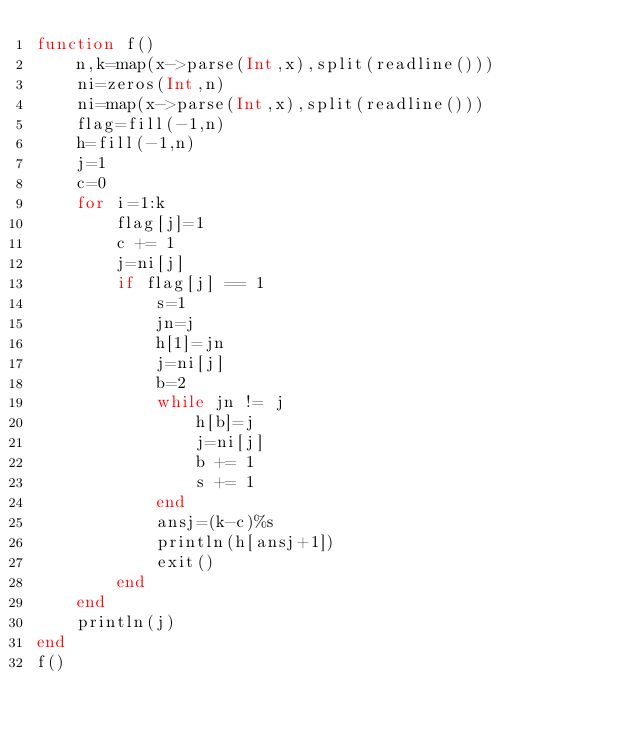Convert code to text. <code><loc_0><loc_0><loc_500><loc_500><_Julia_>function f()
    n,k=map(x->parse(Int,x),split(readline()))
    ni=zeros(Int,n)
    ni=map(x->parse(Int,x),split(readline()))
    flag=fill(-1,n)
    h=fill(-1,n)
    j=1
    c=0
    for i=1:k
        flag[j]=1
        c += 1
        j=ni[j]
        if flag[j] == 1
            s=1
            jn=j
            h[1]=jn
            j=ni[j]
            b=2
            while jn != j
                h[b]=j
                j=ni[j]
                b += 1
                s += 1
            end
            ansj=(k-c)%s
            println(h[ansj+1])
            exit()
        end
    end 
    println(j)  
end
f()           
</code> 